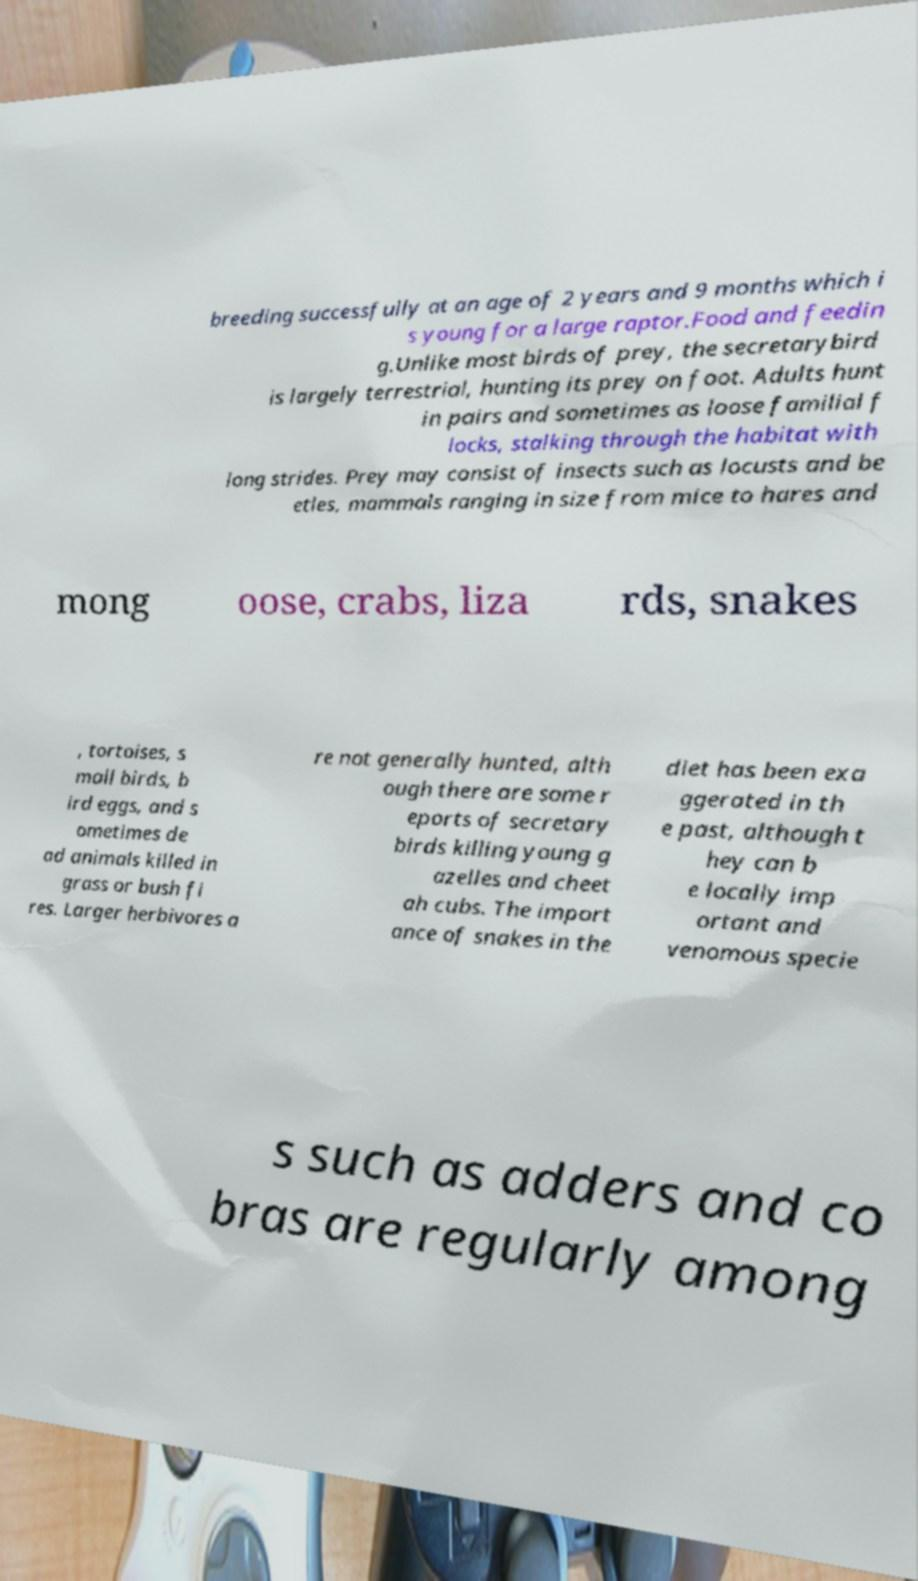I need the written content from this picture converted into text. Can you do that? breeding successfully at an age of 2 years and 9 months which i s young for a large raptor.Food and feedin g.Unlike most birds of prey, the secretarybird is largely terrestrial, hunting its prey on foot. Adults hunt in pairs and sometimes as loose familial f locks, stalking through the habitat with long strides. Prey may consist of insects such as locusts and be etles, mammals ranging in size from mice to hares and mong oose, crabs, liza rds, snakes , tortoises, s mall birds, b ird eggs, and s ometimes de ad animals killed in grass or bush fi res. Larger herbivores a re not generally hunted, alth ough there are some r eports of secretary birds killing young g azelles and cheet ah cubs. The import ance of snakes in the diet has been exa ggerated in th e past, although t hey can b e locally imp ortant and venomous specie s such as adders and co bras are regularly among 